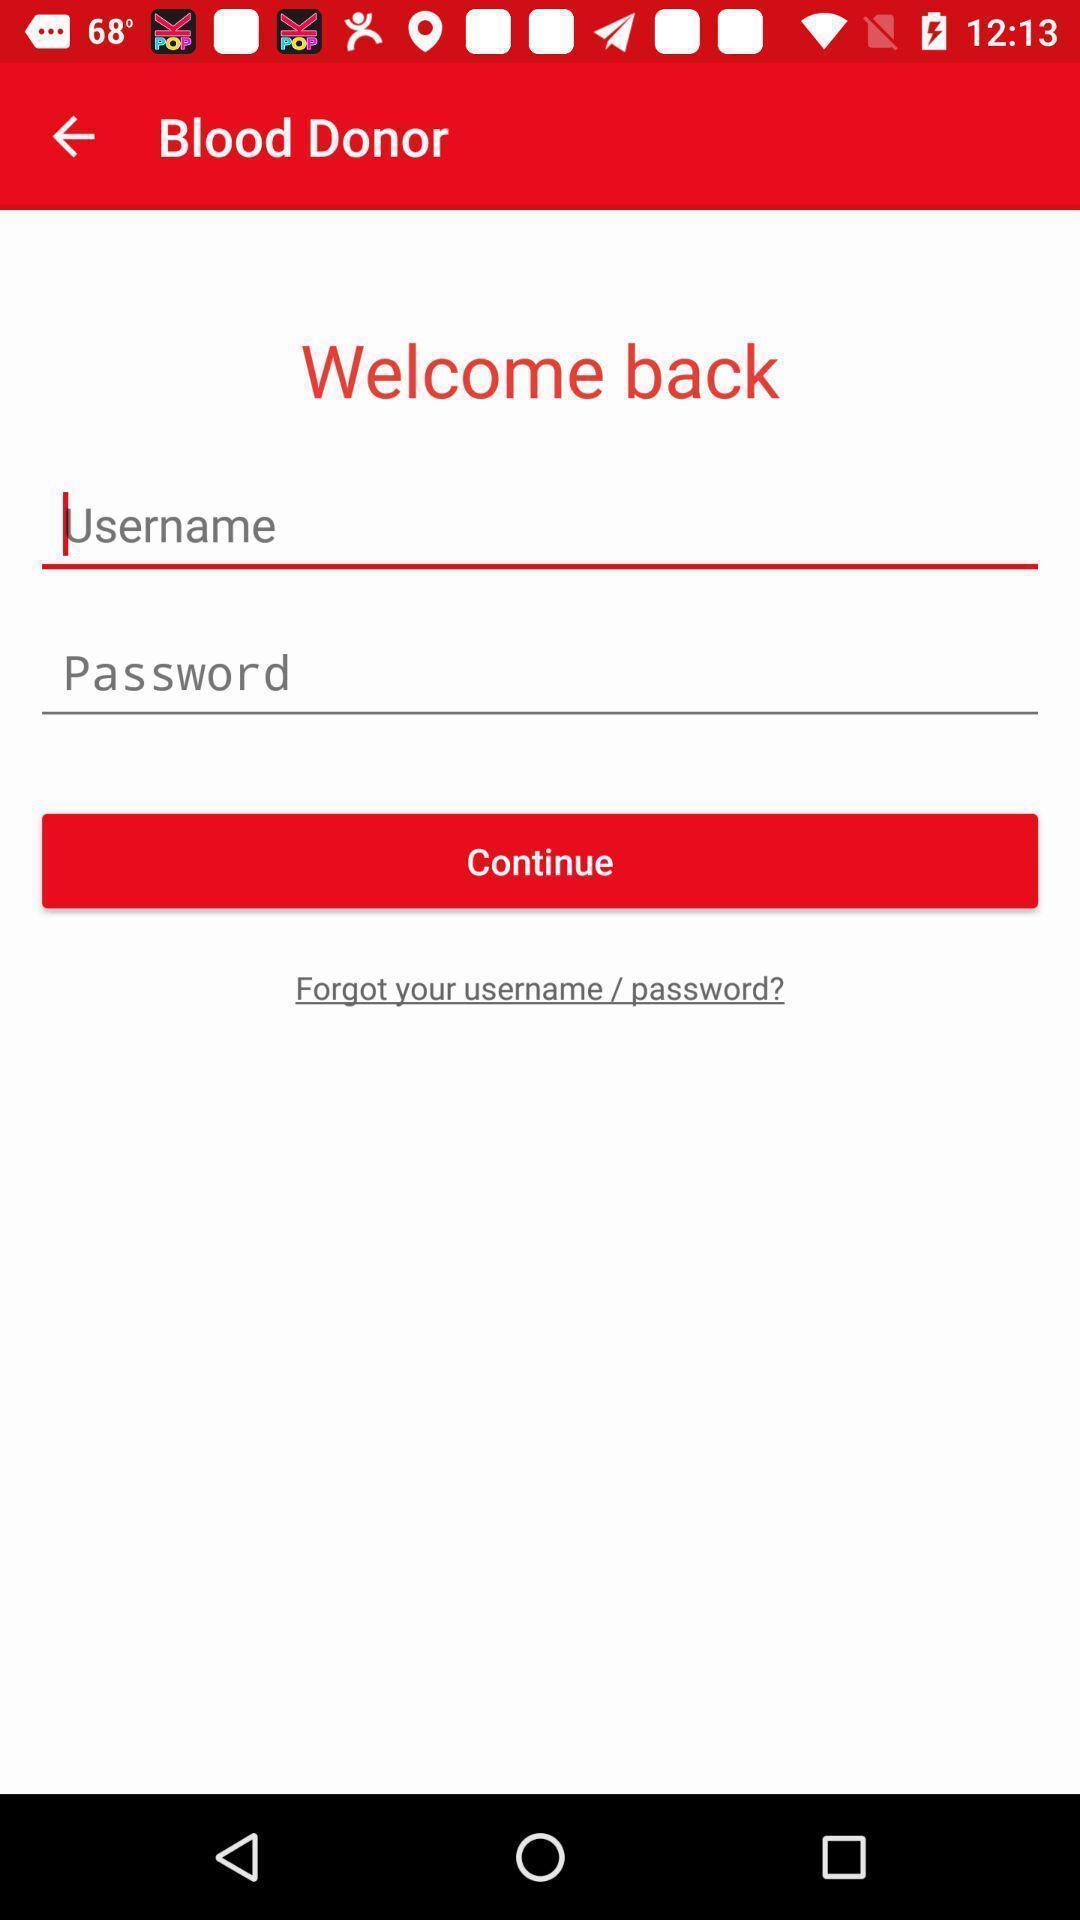Describe the content in this image. Welcome page of a page. 